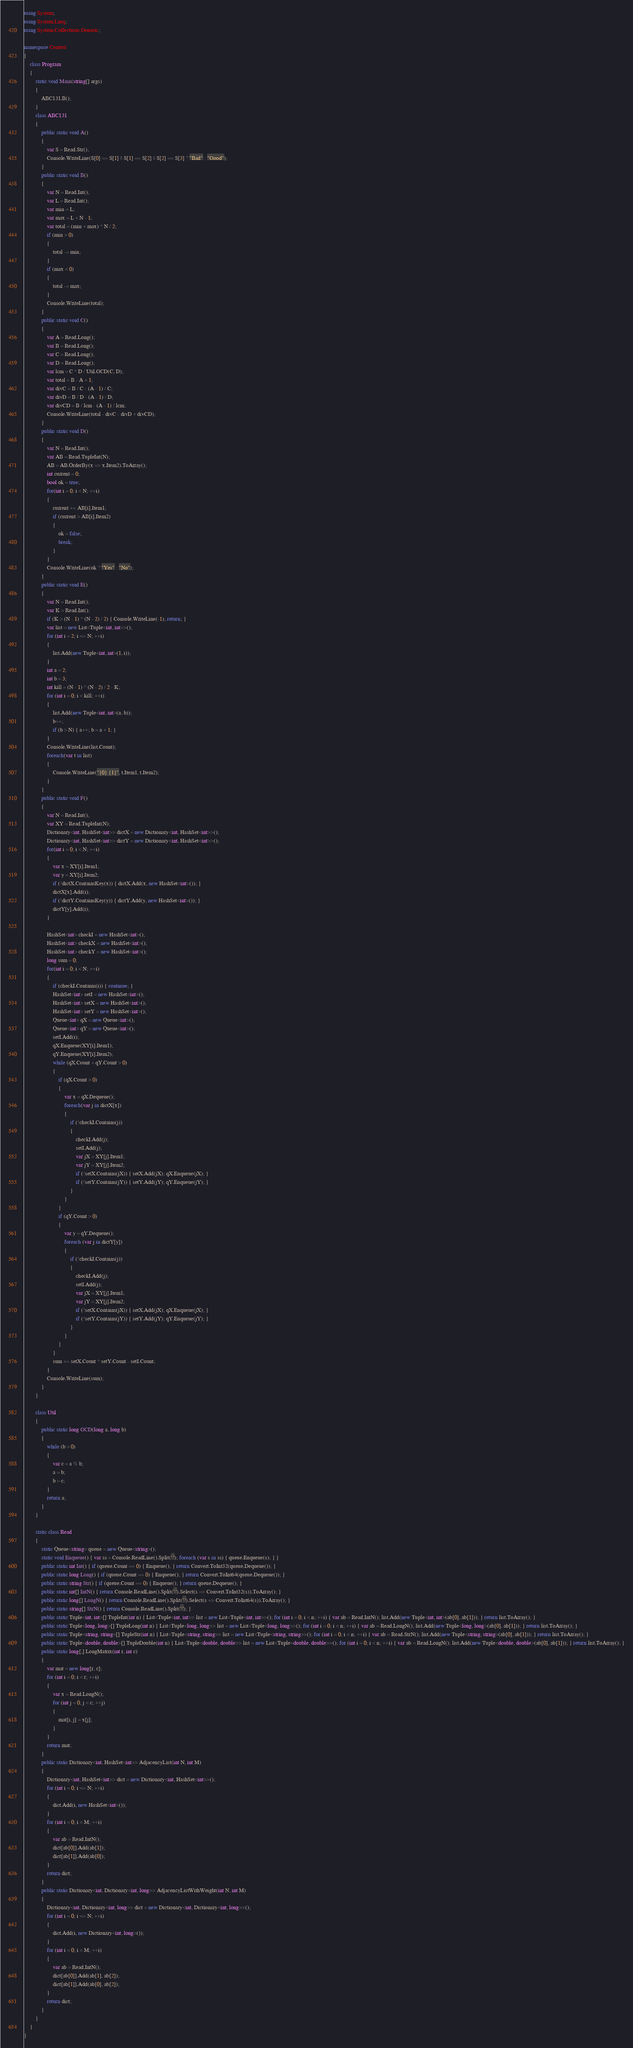<code> <loc_0><loc_0><loc_500><loc_500><_C#_>using System;
using System.Linq;
using System.Collections.Generic;

namespace Contest
{
    class Program
    {
        static void Main(string[] args)
        {
            ABC131.B();
        }
        class ABC131
        {
            public static void A()
            {
                var S = Read.Str();
                Console.WriteLine(S[0] == S[1] || S[1] == S[2] || S[2] == S[3] ? "Bad" : "Good");
            }
            public static void B()
            {
                var N = Read.Int();
                var L = Read.Int();
                var min = L;
                var max = L + N - 1;
                var total = (min + max) * N / 2;
                if (min > 0)
                {
                    total -= min;
                }
                if (max < 0)
                {
                    total -= max;
                }
                Console.WriteLine(total);
            }
            public static void C()
            {
                var A = Read.Long();
                var B = Read.Long();
                var C = Read.Long();
                var D = Read.Long();
                var lcm = C * D / Util.GCD(C, D);
                var total = B - A + 1;
                var divC = B / C - (A - 1) / C;
                var divD = B / D - (A - 1) / D;
                var divCD = B / lcm - (A - 1) / lcm;
                Console.WriteLine(total - divC - divD + divCD);
            }
            public static void D()
            {
                var N = Read.Int();
                var AB = Read.TupleInt(N);
                AB = AB.OrderBy(x => x.Item2).ToArray();
                int current = 0;
                bool ok = true;
                for(int i = 0; i < N; ++i)
                {
                    current += AB[i].Item1;
                    if (current > AB[i].Item2)
                    {
                        ok = false;
                        break;
                    }
                }
                Console.WriteLine(ok ? "Yes" : "No");
            }
            public static void E()
            {
                var N = Read.Int();
                var K = Read.Int();
                if (K > (N - 1) * (N - 2) / 2) { Console.WriteLine(-1); return; }
                var list = new List<Tuple<int, int>>();
                for (int i = 2; i <= N; ++i)
                {
                    list.Add(new Tuple<int, int>(1, i));
                }
                int a = 2;
                int b = 3;
                int kill = (N - 1) * (N - 2) / 2 - K;
                for (int i = 0; i < kill; ++i)
                {
                    list.Add(new Tuple<int, int>(a, b));
                    b++;
                    if (b > N) { a++; b = a + 1; }
                }
                Console.WriteLine(list.Count);
                foreach(var t in list)
                {
                    Console.WriteLine("{0} {1}", t.Item1, t.Item2);
                }
            }
            public static void F()
            {
                var N = Read.Int();
                var XY = Read.TupleInt(N);
                Dictionary<int, HashSet<int>> dictX = new Dictionary<int, HashSet<int>>();
                Dictionary<int, HashSet<int>> dictY = new Dictionary<int, HashSet<int>>();
                for(int i = 0; i < N; ++i)
                {
                    var x = XY[i].Item1;
                    var y = XY[i].Item2;
                    if (!dictX.ContainsKey(x)) { dictX.Add(x, new HashSet<int>()); }
                    dictX[x].Add(i);
                    if (!dictY.ContainsKey(y)) { dictY.Add(y, new HashSet<int>()); }
                    dictY[y].Add(i);
                }

                HashSet<int> checkI = new HashSet<int>();
                HashSet<int> checkX = new HashSet<int>();
                HashSet<int> checkY = new HashSet<int>();
                long sum = 0;
                for(int i = 0; i < N; ++i)
                {
                    if (checkI.Contains(i)) { continue; }
                    HashSet<int> setI = new HashSet<int>();
                    HashSet<int> setX = new HashSet<int>();
                    HashSet<int> setY = new HashSet<int>();
                    Queue<int> qX = new Queue<int>();
                    Queue<int> qY = new Queue<int>();
                    setI.Add(i);
                    qX.Enqueue(XY[i].Item1);
                    qY.Enqueue(XY[i].Item2);
                    while (qX.Count + qY.Count > 0)
                    {
                        if (qX.Count > 0)
                        {
                            var x = qX.Dequeue();
                            foreach(var j in dictX[x])
                            {
                                if (!checkI.Contains(j))
                                {
                                    checkI.Add(j);
                                    setI.Add(j);
                                    var jX = XY[j].Item1;
                                    var jY = XY[j].Item2;
                                    if (!setX.Contains(jX)) { setX.Add(jX); qX.Enqueue(jX); }
                                    if (!setY.Contains(jY)) { setY.Add(jY); qY.Enqueue(jY); }
                                }
                            }
                        }
                        if (qY.Count > 0)
                        {
                            var y = qY.Dequeue();
                            foreach (var j in dictY[y])
                            {
                                if (!checkI.Contains(j))
                                {
                                    checkI.Add(j);
                                    setI.Add(j);
                                    var jX = XY[j].Item1;
                                    var jY = XY[j].Item2;
                                    if (!setX.Contains(jX)) { setX.Add(jX); qX.Enqueue(jX); }
                                    if (!setY.Contains(jY)) { setY.Add(jY); qY.Enqueue(jY); }
                                }
                            }
                        }
                    }
                    sum += setX.Count * setY.Count - setI.Count;
                }
                Console.WriteLine(sum);
            }
        }

        class Util
        {
            public static long GCD(long a, long b)
            {
                while (b > 0)
                {
                    var c = a % b;
                    a = b;
                    b = c;
                }
                return a;
            }
        }

        static class Read
        {
            static Queue<string> queue = new Queue<string>();
            static void Enqueue() { var ss = Console.ReadLine().Split(' '); foreach (var s in ss) { queue.Enqueue(s); } }
            public static int Int() { if (queue.Count == 0) { Enqueue(); } return Convert.ToInt32(queue.Dequeue()); }
            public static long Long() { if (queue.Count == 0) { Enqueue(); } return Convert.ToInt64(queue.Dequeue()); }
            public static string Str() { if (queue.Count == 0) { Enqueue(); } return queue.Dequeue(); }
            public static int[] IntN() { return Console.ReadLine().Split(' ').Select(s => Convert.ToInt32(s)).ToArray(); }
            public static long[] LongN() { return Console.ReadLine().Split(' ').Select(s => Convert.ToInt64(s)).ToArray(); }
            public static string[] StrN() { return Console.ReadLine().Split(' '); }
            public static Tuple<int, int>[] TupleInt(int n) { List<Tuple<int, int>> list = new List<Tuple<int, int>>(); for (int i = 0; i < n; ++i) { var ab = Read.IntN(); list.Add(new Tuple<int, int>(ab[0], ab[1])); } return list.ToArray(); }
            public static Tuple<long, long>[] TupleLong(int n) { List<Tuple<long, long>> list = new List<Tuple<long, long>>(); for (int i = 0; i < n; ++i) { var ab = Read.LongN(); list.Add(new Tuple<long, long>(ab[0], ab[1])); } return list.ToArray(); }
            public static Tuple<string, string>[] TupleStr(int n) { List<Tuple<string, string>> list = new List<Tuple<string, string>>(); for (int i = 0; i < n; ++i) { var ab = Read.StrN(); list.Add(new Tuple<string, string>(ab[0], ab[1])); } return list.ToArray(); }
            public static Tuple<double, double>[] TupleDouble(int n) { List<Tuple<double, double>> list = new List<Tuple<double, double>>(); for (int i = 0; i < n; ++i) { var ab = Read.LongN(); list.Add(new Tuple<double, double>(ab[0], ab[1])); } return list.ToArray(); }
            public static long[,] LongMatrix(int r, int c)
            {
                var mat = new long[r, c];
                for (int i = 0; i < r; ++i)
                {
                    var x = Read.LongN();
                    for (int j = 0; j < c; ++j)
                    {
                        mat[i, j] = x[j];
                    }
                }
                return mat;
            }
            public static Dictionary<int, HashSet<int>> AdjacencyList(int N, int M)
            {
                Dictionary<int, HashSet<int>> dict = new Dictionary<int, HashSet<int>>();
                for (int i = 0; i <= N; ++i)
                {
                    dict.Add(i, new HashSet<int>());
                }
                for (int i = 0; i < M; ++i)
                {
                    var ab = Read.IntN();
                    dict[ab[0]].Add(ab[1]);
                    dict[ab[1]].Add(ab[0]);
                }
                return dict;
            }
            public static Dictionary<int, Dictionary<int, long>> AdjacencyListWithWeight(int N, int M)
            {
                Dictionary<int, Dictionary<int, long>> dict = new Dictionary<int, Dictionary<int, long>>();
                for (int i = 0; i <= N; ++i)
                {
                    dict.Add(i, new Dictionary<int, long>());
                }
                for (int i = 0; i < M; ++i)
                {
                    var ab = Read.IntN();
                    dict[ab[0]].Add(ab[1], ab[2]);
                    dict[ab[1]].Add(ab[0], ab[2]);
                }
                return dict;
            }
        }
    }
}
</code> 